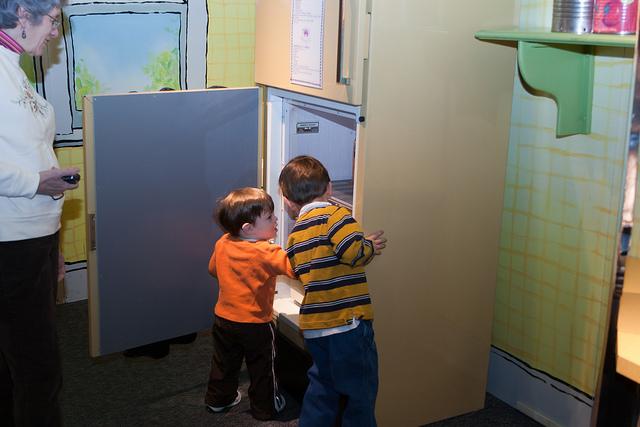What color are the stripes on the boys shirt?
Be succinct. Black and white. What appliance has one open door and one closed door?
Answer briefly. Refrigerator. How many people are in the picture?
Answer briefly. 3. 